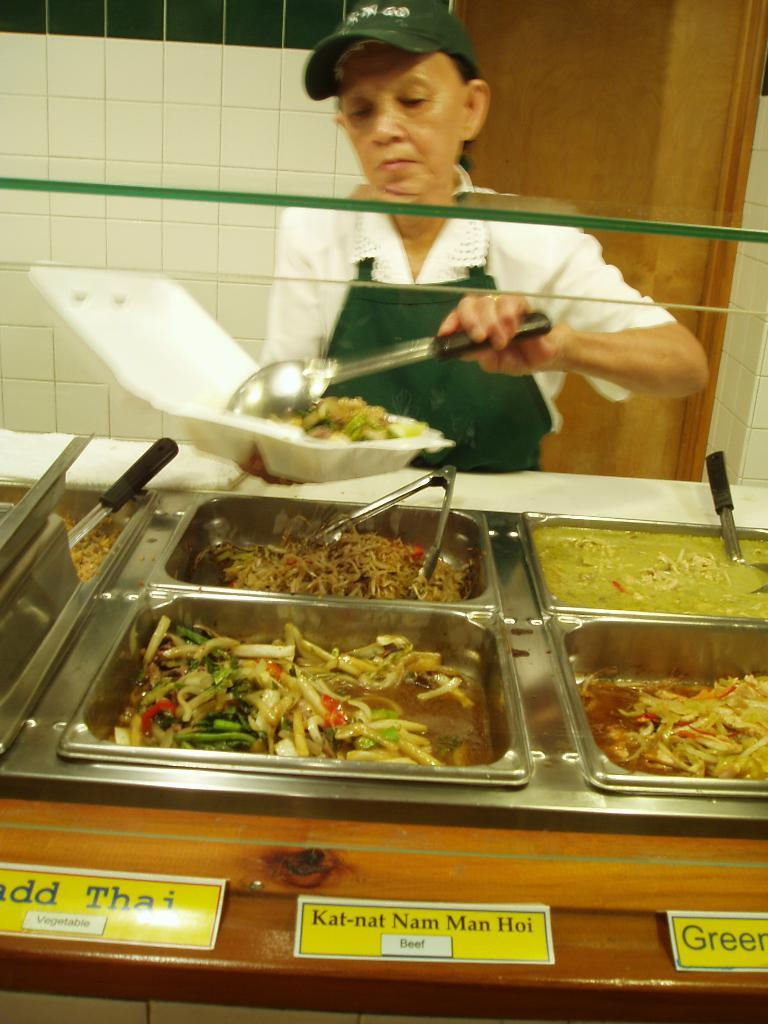Who is the main subject in the image? There is a woman in the image. What is the woman holding in the image? The woman is holding a plate and a spoon. What is in front of the woman on the table? There are bowls containing food in front of the woman. What can be seen at the bottom of the image? There are name boards at the bottom of the image. What country does the woman in the image represent? The image does not provide any information about the country the woman represents. 